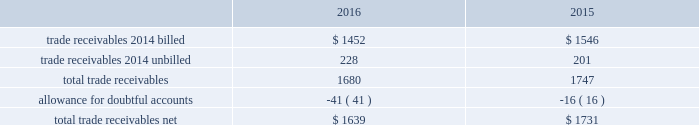Fidelity national information services , inc .
And subsidiaries notes to consolidated financial statements - ( continued ) contingent consideration liabilities recorded in connection with business acquisitions must also be adjusted for changes in fair value until settled .
See note 3 for discussion of the capital markets company bvba ( "capco" ) contingent consideration liability .
( d ) derivative financial instruments the company accounts for derivative financial instruments in accordance with financial accounting standards board accounting standards codification ( 201cfasb asc 201d ) topic 815 , derivatives and hedging .
During 2016 , 2015 and 2014 , the company engaged in g hedging activities relating to its variable rate debt through the use of interest rate swaps .
The company designates these interest rate swaps as cash flow hedges .
The estimated fair values of the cash flow hedges are determined using level 2 type measurements .
Thh ey are recorded as an asset or liability of the company and are included in the accompanying consolidated balance sheets in prepaid expenses and other current assets , other non-current assets , accounts payable and accrued liabilities or other long-term liabilities , as appropriate , and as a component of accumulated other comprehensive earnings , net of deferred taxes .
A portion of the amount included in accumulated other comprehensive earnings is recorded in interest expense as a yield adjustment as interest payments are made on then company 2019s term and revolving loans ( note 10 ) .
The company 2019s existing cash flow hedge is highly effective and there was no impact on 2016 earnings due to hedge ineffectiveness .
It is our policy to execute such instruments with credit-worthy banks and not to enter into derivative financial instruments for speculative purposes .
As of december 31 , 2016 , we believe that our interest rate swap counterparty will be able to fulfill its obligations under our agreement .
The company's foreign exchange risk management policy permits the use of derivative instruments , such as forward contracts and options , to reduce volatility in the company's results of operations and/or cash flows resulting from foreign exchange rate fluctuations .
During 2016 and 2015 , the company entered into foreign currency forward exchange contracts to hedge foreign currency exposure to intercompany loans .
As of december 31 , 2016 and 2015 , the notional amount of these derivatives was approximately $ 143 million and aa $ 81 million , respectively , and the fair value was nominal .
These derivatives have not been designated as hedges for accounting purposes .
We also use currency forward contracts to manage our exposure to fluctuations in costs caused by variations in indian rupee ( "inr" ) ii exchange rates .
As of december 31 , 2016 , the notional amount of these derivatives was approximately $ 7 million and the fair value was l less than $ 1 million , which is included in prepaid expenses and other current assets in the consolidated balance sheets .
These inr forward contracts are designated as cash flow hedges .
The fair value of these currency forward contracts is determined using currency uu exchange market rates , obtained from reliable , independent , third party banks , at the balance sheet date .
The fair value of forward rr contracts is subject to changes in currency exchange rates .
The company has no ineffectiveness related to its use of currency forward ff contracts in connection with inr cash flow hedges .
In september 2015 , the company entered into treasury lock hedges with a total notional amount of $ 1.0 billion , reducing the risk of changes in the benchmark index component of the 10-year treasury yield .
The company def signated these derivatives as cash flow hedges .
On october 13 , 2015 , in conjunction with the pricing of the $ 4.5 billion senior notes , the companyr terminated these treasury lock contracts for a cash settlement payment of $ 16 million , which was recorded as a component of other comprehensive earnings and will be reclassified as an adjustment to interest expense over the ten years during which the related interest payments that were hedged will be recognized in income .
( e ) trade receivables a summary of trade receivables , net , as of december 31 , 2016 and 2015 is as follows ( in millions ) : .

What was the change in millions of total trade receivables net from 2015 to 2016? 
Computations: (1639 - 1731)
Answer: -92.0. 